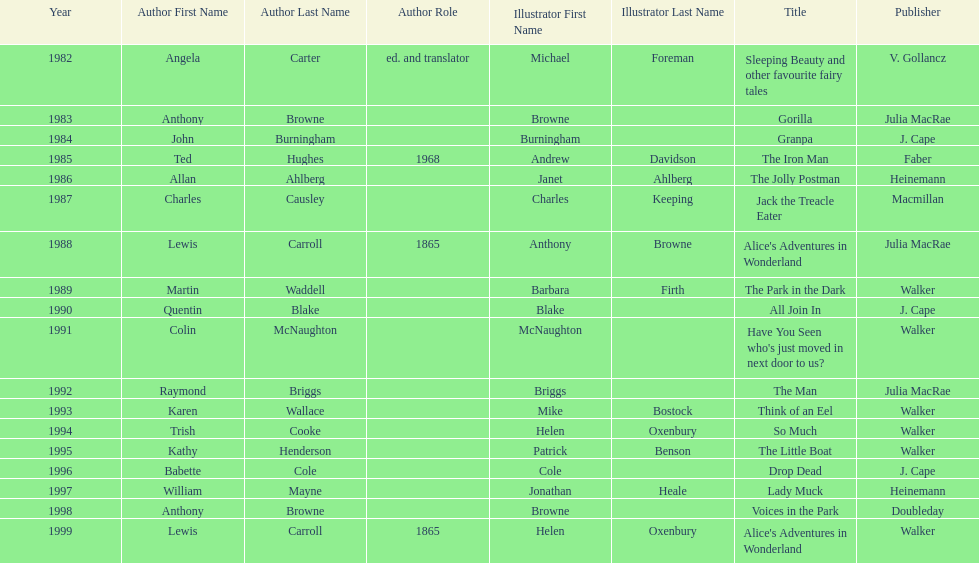How many number of titles are listed for the year 1991? 1. 